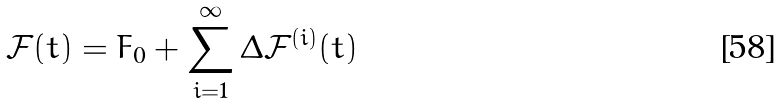<formula> <loc_0><loc_0><loc_500><loc_500>\mathcal { F } ( t ) = F _ { 0 } + \sum _ { i = 1 } ^ { \infty } \Delta \mathcal { F } ^ { ( i ) } ( t )</formula> 